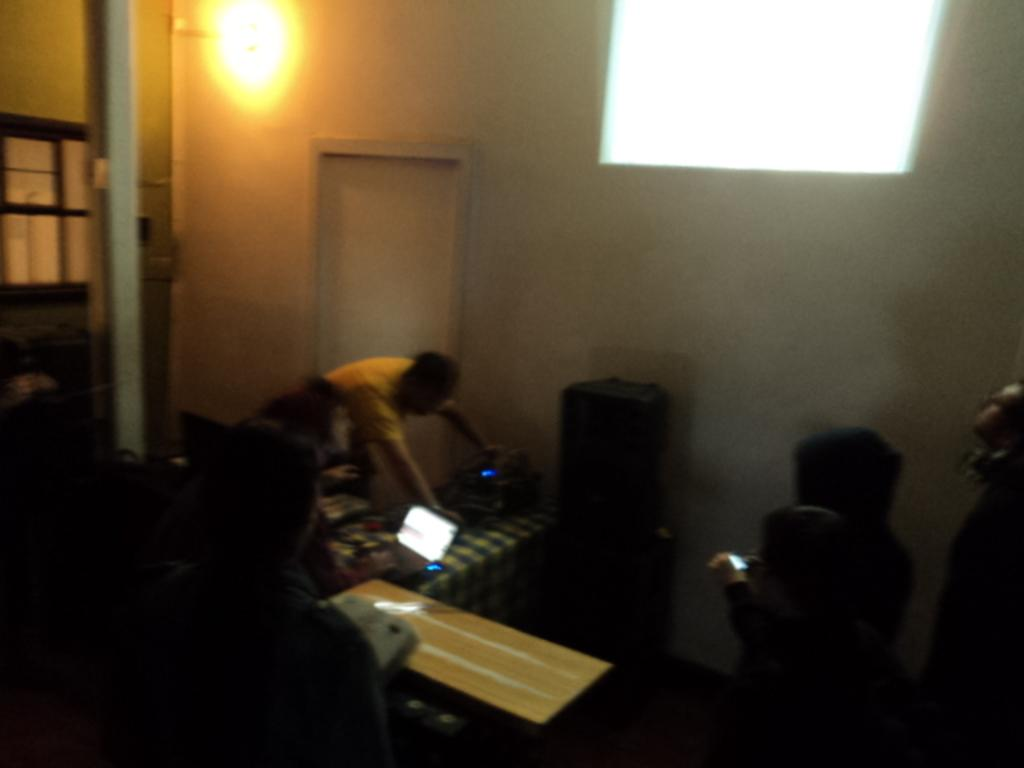Who or what is present in the image? There are people in the image. What electronic device can be seen in the image? There is a laptop in the image. What architectural features are visible in the background of the image? There is a wall and a door in the background of the image. What source of illumination is present in the background of the image? There is a light in the background of the image. What hand gesture is the dad making in the image? There is no dad present in the image, and no hand gestures can be observed. 